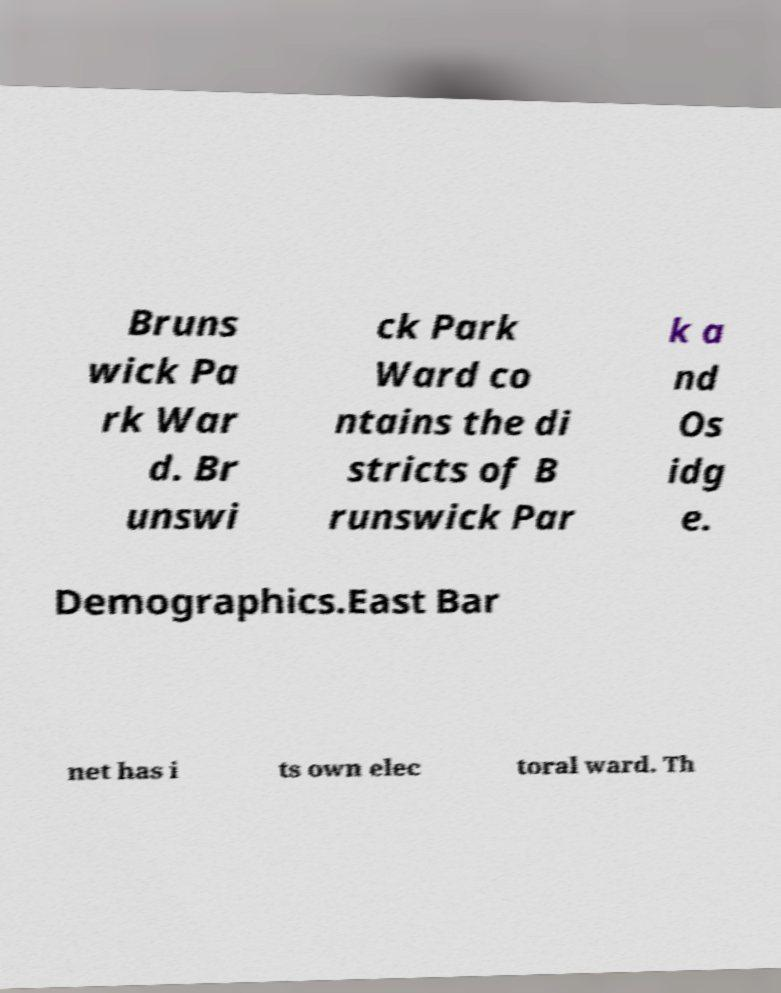Can you read and provide the text displayed in the image?This photo seems to have some interesting text. Can you extract and type it out for me? Bruns wick Pa rk War d. Br unswi ck Park Ward co ntains the di stricts of B runswick Par k a nd Os idg e. Demographics.East Bar net has i ts own elec toral ward. Th 